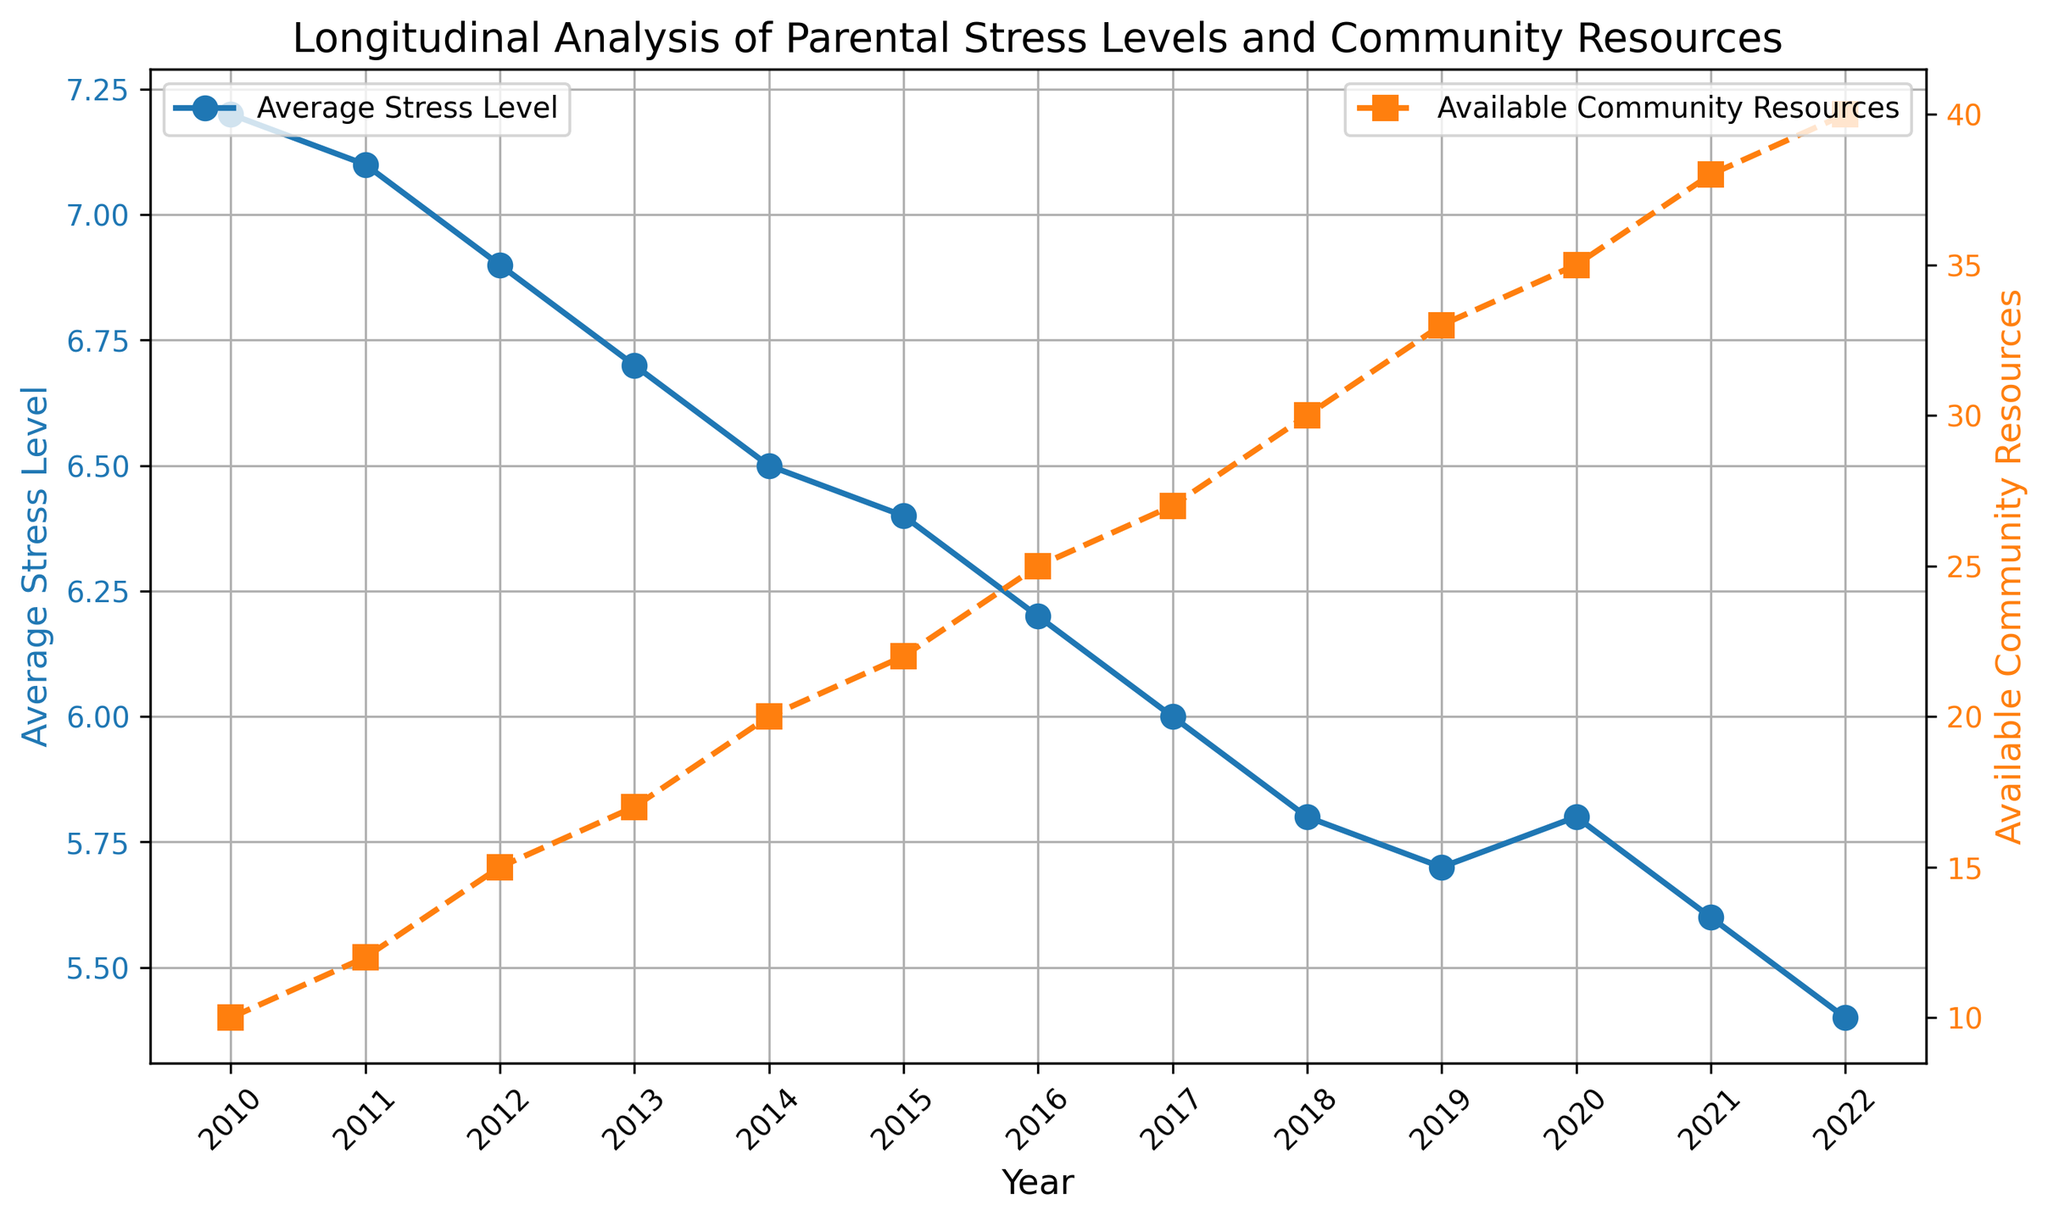What was the average stress level in 2014? The value on the graph for the average stress level in 2014 is 6.5. This is visualized by a blue line with markers.
Answer: 6.5 How did the available community resources change from 2012 to 2013? The graph shows that the available community resources increased from 15 in 2012 to 17 in 2013.
Answer: Increased by 2 What year had the highest average stress level? The graph indicates that in 2010, the average stress level was the highest, at 7.2.
Answer: 2010 Compare the average stress levels between 2017 and 2018. Which year had a lower stress level, and by how much? In 2017, the average stress level was 6.0, and in 2018, it was 5.8. To find the difference: 6.0 - 5.8 = 0.2.
Answer: 2018, by 0.2 What is the overall trend of the average stress levels from 2010 to 2022? The graph shows a consistent downward trend in average stress levels from 2010 (7.2) to 2022 (5.4).
Answer: Decreasing Which year had the highest number of available community resources? The graph illustrates that in 2022, the number of available community resources was the highest, at 40.
Answer: 2022 Compare the year with the lowest average stress level to the year with the highest number of available community resources. Are they the same year? The year with the lowest average stress level is 2022 (5.4), and the year with the highest number of available community resources is also 2022 (40).
Answer: Yes Calculate the total increase in available community resources from 2010 to 2022. The available community resources in 2010 were 10, and in 2022 were 40. The total increase is 40 - 10 = 30.
Answer: 30 What was the average stress level when the available community resources reached 30? The available community resources reached 30 in 2018, and the average stress level for that year was 5.8.
Answer: 5.8 Is there a correlation between the average stress levels and available community resources from 2010 to 2022? The graph shows that as the number of available community resources increased from 10 to 40, the average stress levels decreased from 7.2 to 5.4, suggesting a negative correlation.
Answer: Negative correlation 